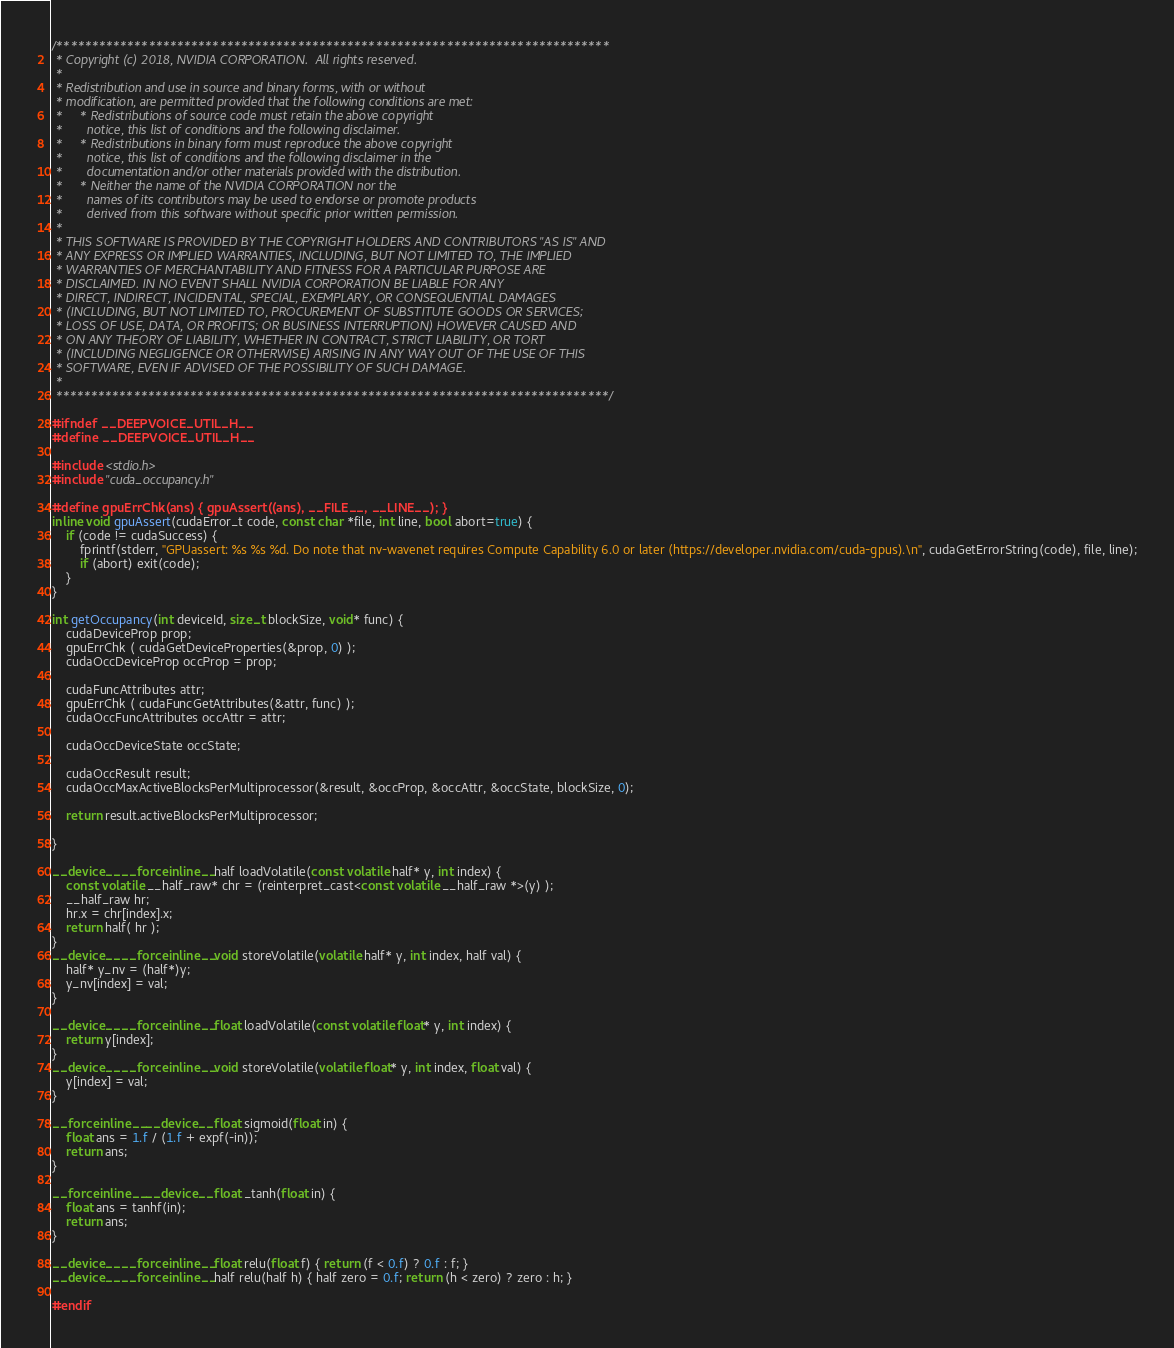Convert code to text. <code><loc_0><loc_0><loc_500><loc_500><_Cuda_>/******************************************************************************
 * Copyright (c) 2018, NVIDIA CORPORATION.  All rights reserved.
 *
 * Redistribution and use in source and binary forms, with or without
 * modification, are permitted provided that the following conditions are met:
 *     * Redistributions of source code must retain the above copyright
 *       notice, this list of conditions and the following disclaimer.
 *     * Redistributions in binary form must reproduce the above copyright
 *       notice, this list of conditions and the following disclaimer in the
 *       documentation and/or other materials provided with the distribution.
 *     * Neither the name of the NVIDIA CORPORATION nor the
 *       names of its contributors may be used to endorse or promote products
 *       derived from this software without specific prior written permission.
 *
 * THIS SOFTWARE IS PROVIDED BY THE COPYRIGHT HOLDERS AND CONTRIBUTORS "AS IS" AND
 * ANY EXPRESS OR IMPLIED WARRANTIES, INCLUDING, BUT NOT LIMITED TO, THE IMPLIED
 * WARRANTIES OF MERCHANTABILITY AND FITNESS FOR A PARTICULAR PURPOSE ARE
 * DISCLAIMED. IN NO EVENT SHALL NVIDIA CORPORATION BE LIABLE FOR ANY
 * DIRECT, INDIRECT, INCIDENTAL, SPECIAL, EXEMPLARY, OR CONSEQUENTIAL DAMAGES
 * (INCLUDING, BUT NOT LIMITED TO, PROCUREMENT OF SUBSTITUTE GOODS OR SERVICES;
 * LOSS OF USE, DATA, OR PROFITS; OR BUSINESS INTERRUPTION) HOWEVER CAUSED AND
 * ON ANY THEORY OF LIABILITY, WHETHER IN CONTRACT, STRICT LIABILITY, OR TORT
 * (INCLUDING NEGLIGENCE OR OTHERWISE) ARISING IN ANY WAY OUT OF THE USE OF THIS
 * SOFTWARE, EVEN IF ADVISED OF THE POSSIBILITY OF SUCH DAMAGE.
 *
 ******************************************************************************/

#ifndef __DEEPVOICE_UTIL_H__
#define __DEEPVOICE_UTIL_H__

#include <stdio.h>
#include "cuda_occupancy.h"

#define gpuErrChk(ans) { gpuAssert((ans), __FILE__, __LINE__); }
inline void gpuAssert(cudaError_t code, const char *file, int line, bool abort=true) {
    if (code != cudaSuccess) {
        fprintf(stderr, "GPUassert: %s %s %d. Do note that nv-wavenet requires Compute Capability 6.0 or later (https://developer.nvidia.com/cuda-gpus).\n", cudaGetErrorString(code), file, line);
        if (abort) exit(code);
    }
}

int getOccupancy(int deviceId, size_t blockSize, void* func) {
    cudaDeviceProp prop;
    gpuErrChk ( cudaGetDeviceProperties(&prop, 0) );
    cudaOccDeviceProp occProp = prop;

    cudaFuncAttributes attr;
    gpuErrChk ( cudaFuncGetAttributes(&attr, func) );
    cudaOccFuncAttributes occAttr = attr;

    cudaOccDeviceState occState;

    cudaOccResult result;
    cudaOccMaxActiveBlocksPerMultiprocessor(&result, &occProp, &occAttr, &occState, blockSize, 0);

    return result.activeBlocksPerMultiprocessor;

}

__device__ __forceinline__ half loadVolatile(const volatile half* y, int index) {
    const volatile __half_raw* chr = (reinterpret_cast<const volatile __half_raw *>(y) );
    __half_raw hr;
    hr.x = chr[index].x;
    return half( hr );
}
__device__ __forceinline__ void storeVolatile(volatile half* y, int index, half val) {
    half* y_nv = (half*)y;
    y_nv[index] = val;
}

__device__ __forceinline__ float loadVolatile(const volatile float* y, int index) {
    return y[index];
}
__device__ __forceinline__ void storeVolatile(volatile float* y, int index, float val) {
    y[index] = val;
}

__forceinline__ __device__ float sigmoid(float in) {
    float ans = 1.f / (1.f + expf(-in));
    return ans;
}

__forceinline__ __device__ float _tanh(float in) {
    float ans = tanhf(in);
    return ans;
}

__device__ __forceinline__ float relu(float f) { return (f < 0.f) ? 0.f : f; }
__device__ __forceinline__ half relu(half h) { half zero = 0.f; return (h < zero) ? zero : h; }

#endif
</code> 